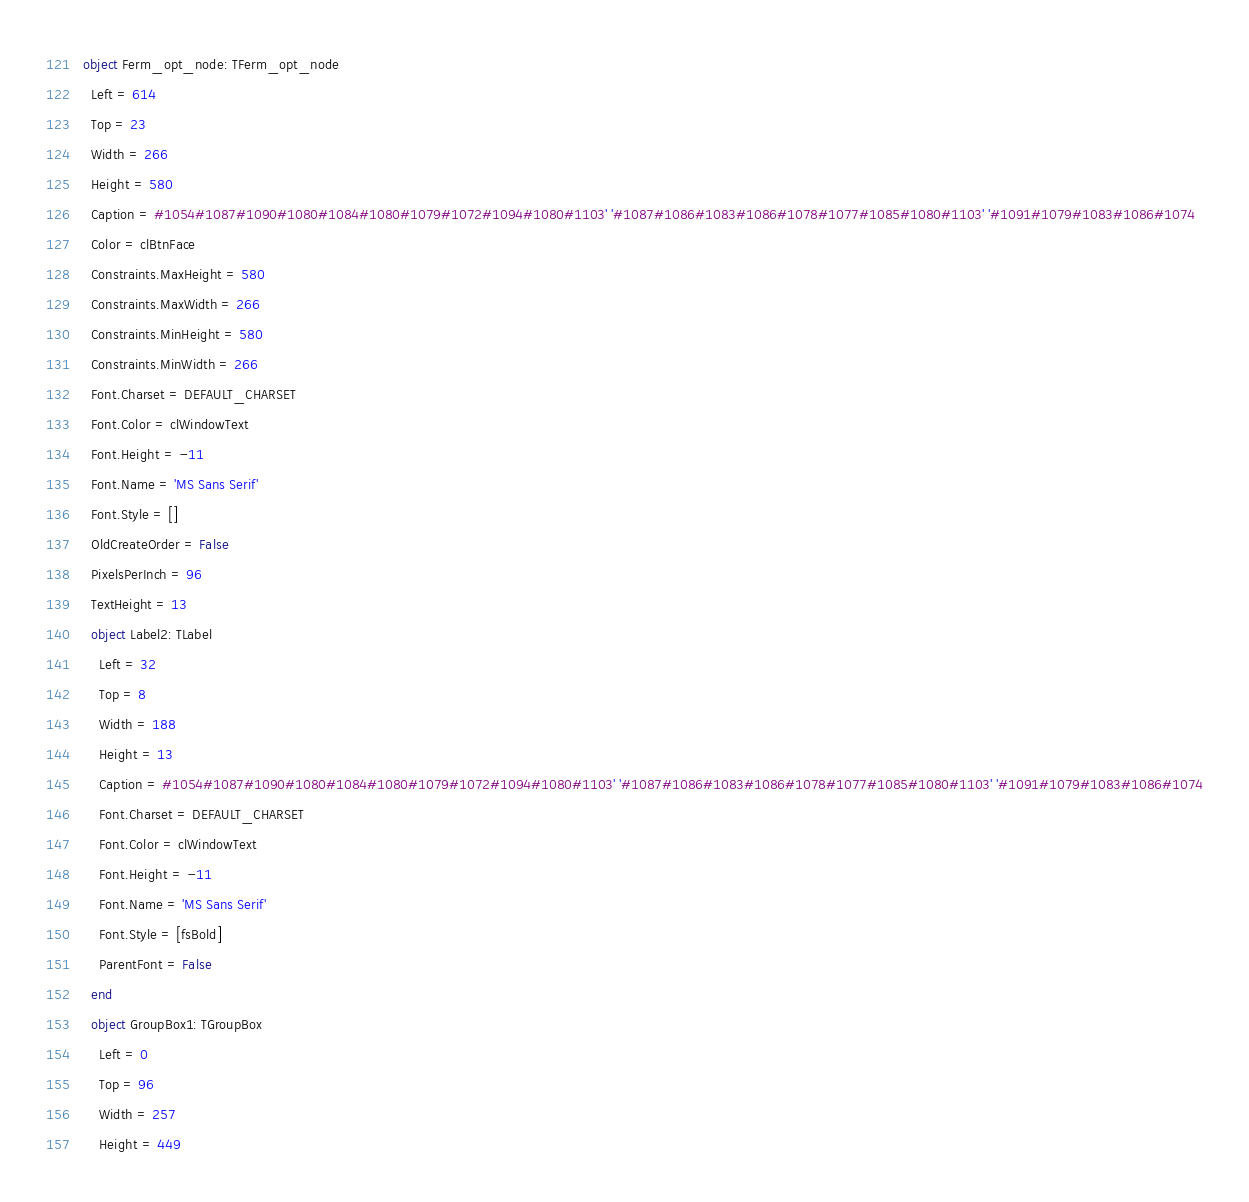Convert code to text. <code><loc_0><loc_0><loc_500><loc_500><_Pascal_>object Ferm_opt_node: TFerm_opt_node
  Left = 614
  Top = 23
  Width = 266
  Height = 580
  Caption = #1054#1087#1090#1080#1084#1080#1079#1072#1094#1080#1103' '#1087#1086#1083#1086#1078#1077#1085#1080#1103' '#1091#1079#1083#1086#1074
  Color = clBtnFace
  Constraints.MaxHeight = 580
  Constraints.MaxWidth = 266
  Constraints.MinHeight = 580
  Constraints.MinWidth = 266
  Font.Charset = DEFAULT_CHARSET
  Font.Color = clWindowText
  Font.Height = -11
  Font.Name = 'MS Sans Serif'
  Font.Style = []
  OldCreateOrder = False
  PixelsPerInch = 96
  TextHeight = 13
  object Label2: TLabel
    Left = 32
    Top = 8
    Width = 188
    Height = 13
    Caption = #1054#1087#1090#1080#1084#1080#1079#1072#1094#1080#1103' '#1087#1086#1083#1086#1078#1077#1085#1080#1103' '#1091#1079#1083#1086#1074
    Font.Charset = DEFAULT_CHARSET
    Font.Color = clWindowText
    Font.Height = -11
    Font.Name = 'MS Sans Serif'
    Font.Style = [fsBold]
    ParentFont = False
  end
  object GroupBox1: TGroupBox
    Left = 0
    Top = 96
    Width = 257
    Height = 449</code> 